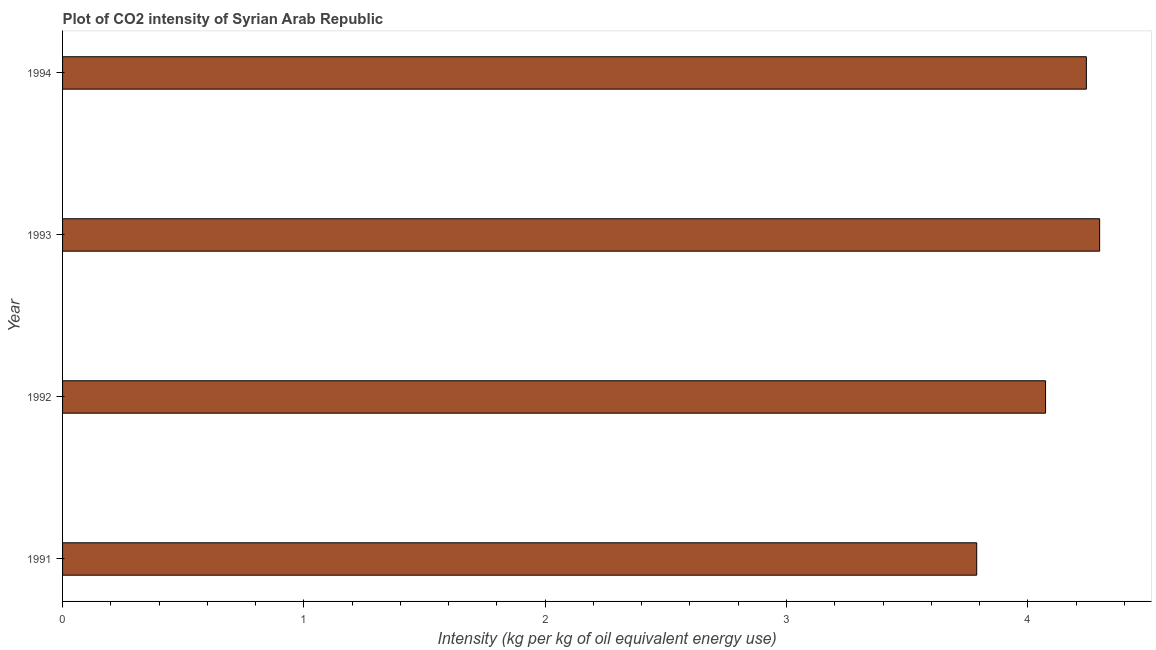What is the title of the graph?
Give a very brief answer. Plot of CO2 intensity of Syrian Arab Republic. What is the label or title of the X-axis?
Ensure brevity in your answer.  Intensity (kg per kg of oil equivalent energy use). What is the co2 intensity in 1991?
Your answer should be compact. 3.79. Across all years, what is the maximum co2 intensity?
Provide a short and direct response. 4.3. Across all years, what is the minimum co2 intensity?
Your response must be concise. 3.79. In which year was the co2 intensity minimum?
Ensure brevity in your answer.  1991. What is the sum of the co2 intensity?
Offer a terse response. 16.4. What is the difference between the co2 intensity in 1991 and 1993?
Provide a succinct answer. -0.51. What is the average co2 intensity per year?
Your answer should be compact. 4.1. What is the median co2 intensity?
Offer a terse response. 4.16. In how many years, is the co2 intensity greater than 1.8 kg?
Your response must be concise. 4. Do a majority of the years between 1991 and 1994 (inclusive) have co2 intensity greater than 4.2 kg?
Your response must be concise. No. Is the co2 intensity in 1993 less than that in 1994?
Give a very brief answer. No. Is the difference between the co2 intensity in 1991 and 1993 greater than the difference between any two years?
Offer a very short reply. Yes. What is the difference between the highest and the second highest co2 intensity?
Make the answer very short. 0.06. What is the difference between the highest and the lowest co2 intensity?
Your answer should be very brief. 0.51. Are all the bars in the graph horizontal?
Your response must be concise. Yes. How many years are there in the graph?
Keep it short and to the point. 4. What is the difference between two consecutive major ticks on the X-axis?
Ensure brevity in your answer.  1. Are the values on the major ticks of X-axis written in scientific E-notation?
Provide a succinct answer. No. What is the Intensity (kg per kg of oil equivalent energy use) of 1991?
Your answer should be compact. 3.79. What is the Intensity (kg per kg of oil equivalent energy use) in 1992?
Make the answer very short. 4.07. What is the Intensity (kg per kg of oil equivalent energy use) in 1993?
Your answer should be very brief. 4.3. What is the Intensity (kg per kg of oil equivalent energy use) of 1994?
Ensure brevity in your answer.  4.24. What is the difference between the Intensity (kg per kg of oil equivalent energy use) in 1991 and 1992?
Provide a short and direct response. -0.29. What is the difference between the Intensity (kg per kg of oil equivalent energy use) in 1991 and 1993?
Offer a very short reply. -0.51. What is the difference between the Intensity (kg per kg of oil equivalent energy use) in 1991 and 1994?
Offer a very short reply. -0.45. What is the difference between the Intensity (kg per kg of oil equivalent energy use) in 1992 and 1993?
Provide a succinct answer. -0.22. What is the difference between the Intensity (kg per kg of oil equivalent energy use) in 1992 and 1994?
Your response must be concise. -0.17. What is the difference between the Intensity (kg per kg of oil equivalent energy use) in 1993 and 1994?
Give a very brief answer. 0.06. What is the ratio of the Intensity (kg per kg of oil equivalent energy use) in 1991 to that in 1993?
Keep it short and to the point. 0.88. What is the ratio of the Intensity (kg per kg of oil equivalent energy use) in 1991 to that in 1994?
Offer a very short reply. 0.89. What is the ratio of the Intensity (kg per kg of oil equivalent energy use) in 1992 to that in 1993?
Offer a terse response. 0.95. 